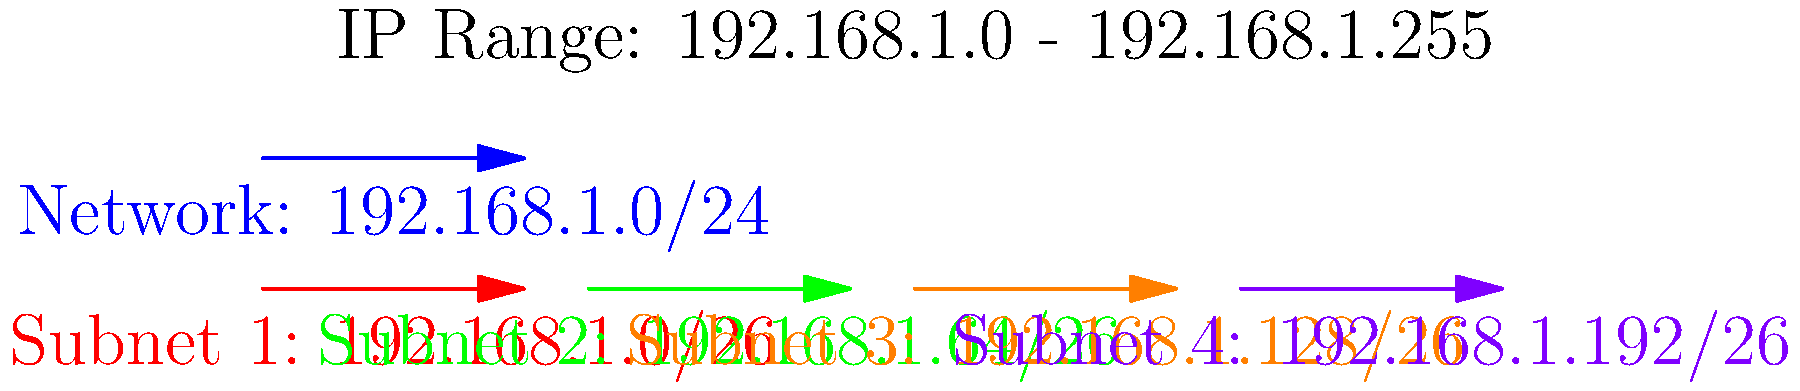In the given subnetting diagram, which subnet would the IP address 192.168.1.150 belong to? Explain your reasoning based on the subnet ranges shown. To determine which subnet the IP address 192.168.1.150 belongs to, we need to analyze the subnet ranges shown in the diagram:

1. The network 192.168.1.0/24 is divided into four equal subnets, each with a /26 prefix.
2. The subnets are:
   - Subnet 1: 192.168.1.0/26
   - Subnet 2: 192.168.1.64/26
   - Subnet 3: 192.168.1.128/26
   - Subnet 4: 192.168.1.192/26

3. To find the range of each subnet, we need to calculate the number of addresses in each:
   - A /26 subnet has $2^{32-26} = 2^6 = 64$ addresses

4. The ranges for each subnet are:
   - Subnet 1: 192.168.1.0 - 192.168.1.63
   - Subnet 2: 192.168.1.64 - 192.168.1.127
   - Subnet 3: 192.168.1.128 - 192.168.1.191
   - Subnet 4: 192.168.1.192 - 192.168.1.255

5. The IP address 192.168.1.150 falls within the range of Subnet 3 (192.168.1.128 - 192.168.1.191).

Therefore, the IP address 192.168.1.150 belongs to Subnet 3 (192.168.1.128/26).
Answer: Subnet 3 (192.168.1.128/26) 